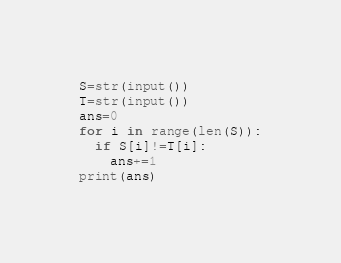Convert code to text. <code><loc_0><loc_0><loc_500><loc_500><_Python_>S=str(input())
T=str(input())
ans=0
for i in range(len(S)):
  if S[i]!=T[i]:
    ans+=1
print(ans)</code> 